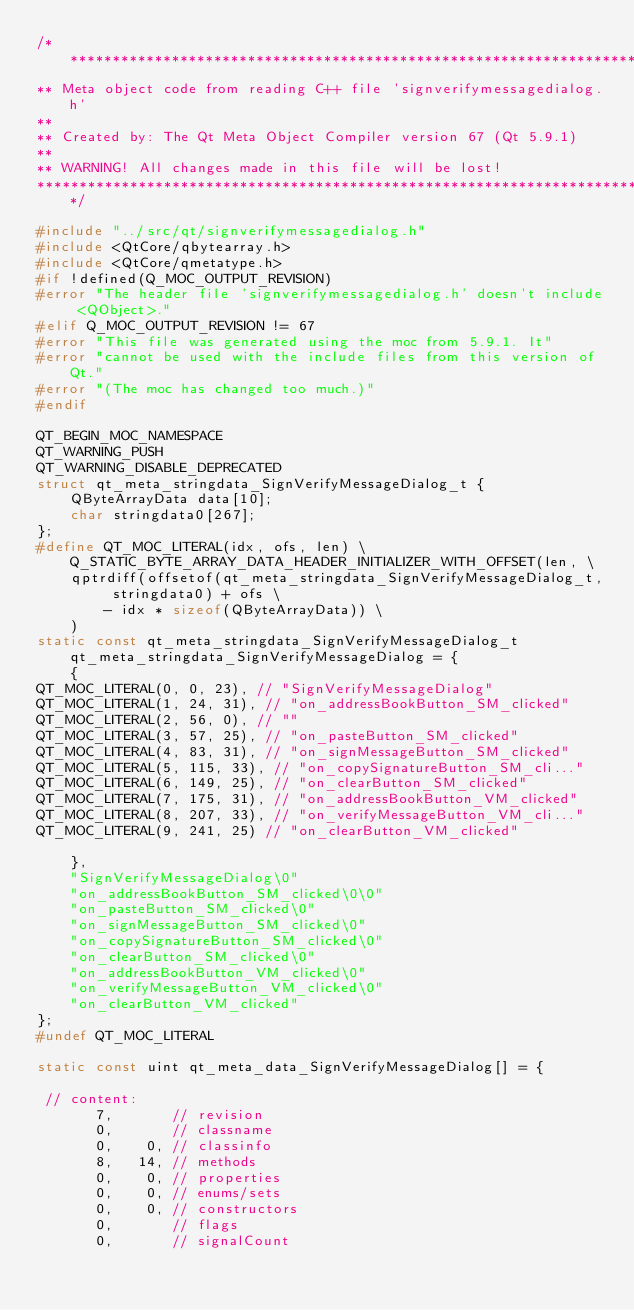<code> <loc_0><loc_0><loc_500><loc_500><_C++_>/****************************************************************************
** Meta object code from reading C++ file 'signverifymessagedialog.h'
**
** Created by: The Qt Meta Object Compiler version 67 (Qt 5.9.1)
**
** WARNING! All changes made in this file will be lost!
*****************************************************************************/

#include "../src/qt/signverifymessagedialog.h"
#include <QtCore/qbytearray.h>
#include <QtCore/qmetatype.h>
#if !defined(Q_MOC_OUTPUT_REVISION)
#error "The header file 'signverifymessagedialog.h' doesn't include <QObject>."
#elif Q_MOC_OUTPUT_REVISION != 67
#error "This file was generated using the moc from 5.9.1. It"
#error "cannot be used with the include files from this version of Qt."
#error "(The moc has changed too much.)"
#endif

QT_BEGIN_MOC_NAMESPACE
QT_WARNING_PUSH
QT_WARNING_DISABLE_DEPRECATED
struct qt_meta_stringdata_SignVerifyMessageDialog_t {
    QByteArrayData data[10];
    char stringdata0[267];
};
#define QT_MOC_LITERAL(idx, ofs, len) \
    Q_STATIC_BYTE_ARRAY_DATA_HEADER_INITIALIZER_WITH_OFFSET(len, \
    qptrdiff(offsetof(qt_meta_stringdata_SignVerifyMessageDialog_t, stringdata0) + ofs \
        - idx * sizeof(QByteArrayData)) \
    )
static const qt_meta_stringdata_SignVerifyMessageDialog_t qt_meta_stringdata_SignVerifyMessageDialog = {
    {
QT_MOC_LITERAL(0, 0, 23), // "SignVerifyMessageDialog"
QT_MOC_LITERAL(1, 24, 31), // "on_addressBookButton_SM_clicked"
QT_MOC_LITERAL(2, 56, 0), // ""
QT_MOC_LITERAL(3, 57, 25), // "on_pasteButton_SM_clicked"
QT_MOC_LITERAL(4, 83, 31), // "on_signMessageButton_SM_clicked"
QT_MOC_LITERAL(5, 115, 33), // "on_copySignatureButton_SM_cli..."
QT_MOC_LITERAL(6, 149, 25), // "on_clearButton_SM_clicked"
QT_MOC_LITERAL(7, 175, 31), // "on_addressBookButton_VM_clicked"
QT_MOC_LITERAL(8, 207, 33), // "on_verifyMessageButton_VM_cli..."
QT_MOC_LITERAL(9, 241, 25) // "on_clearButton_VM_clicked"

    },
    "SignVerifyMessageDialog\0"
    "on_addressBookButton_SM_clicked\0\0"
    "on_pasteButton_SM_clicked\0"
    "on_signMessageButton_SM_clicked\0"
    "on_copySignatureButton_SM_clicked\0"
    "on_clearButton_SM_clicked\0"
    "on_addressBookButton_VM_clicked\0"
    "on_verifyMessageButton_VM_clicked\0"
    "on_clearButton_VM_clicked"
};
#undef QT_MOC_LITERAL

static const uint qt_meta_data_SignVerifyMessageDialog[] = {

 // content:
       7,       // revision
       0,       // classname
       0,    0, // classinfo
       8,   14, // methods
       0,    0, // properties
       0,    0, // enums/sets
       0,    0, // constructors
       0,       // flags
       0,       // signalCount
</code> 